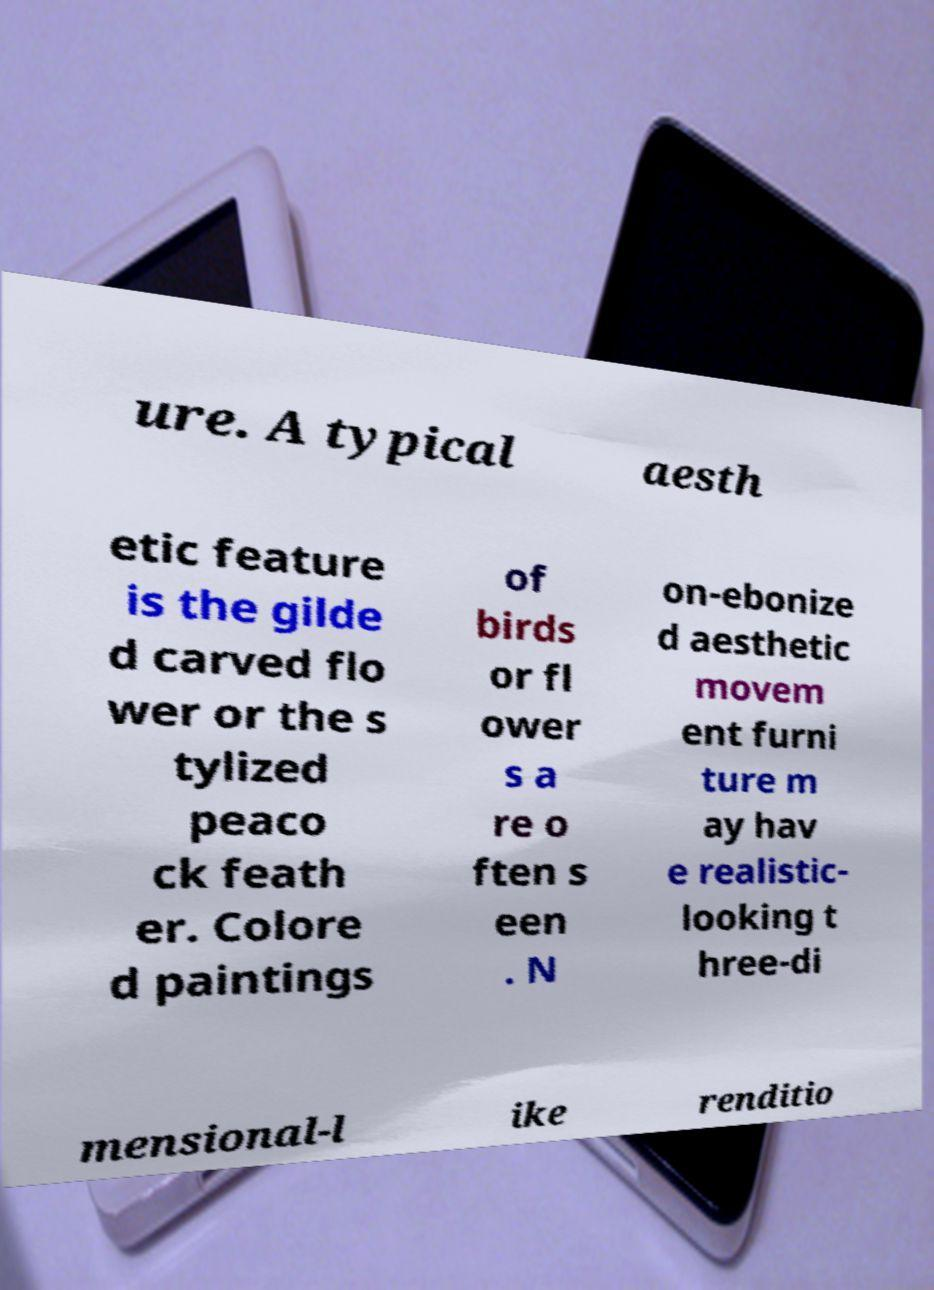Please identify and transcribe the text found in this image. ure. A typical aesth etic feature is the gilde d carved flo wer or the s tylized peaco ck feath er. Colore d paintings of birds or fl ower s a re o ften s een . N on-ebonize d aesthetic movem ent furni ture m ay hav e realistic- looking t hree-di mensional-l ike renditio 